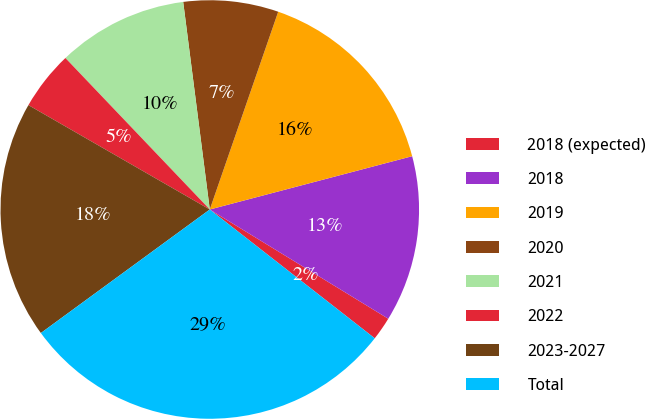Convert chart. <chart><loc_0><loc_0><loc_500><loc_500><pie_chart><fcel>2018 (expected)<fcel>2018<fcel>2019<fcel>2020<fcel>2021<fcel>2022<fcel>2023-2027<fcel>Total<nl><fcel>1.81%<fcel>12.84%<fcel>15.6%<fcel>7.33%<fcel>10.09%<fcel>4.57%<fcel>18.36%<fcel>29.4%<nl></chart> 